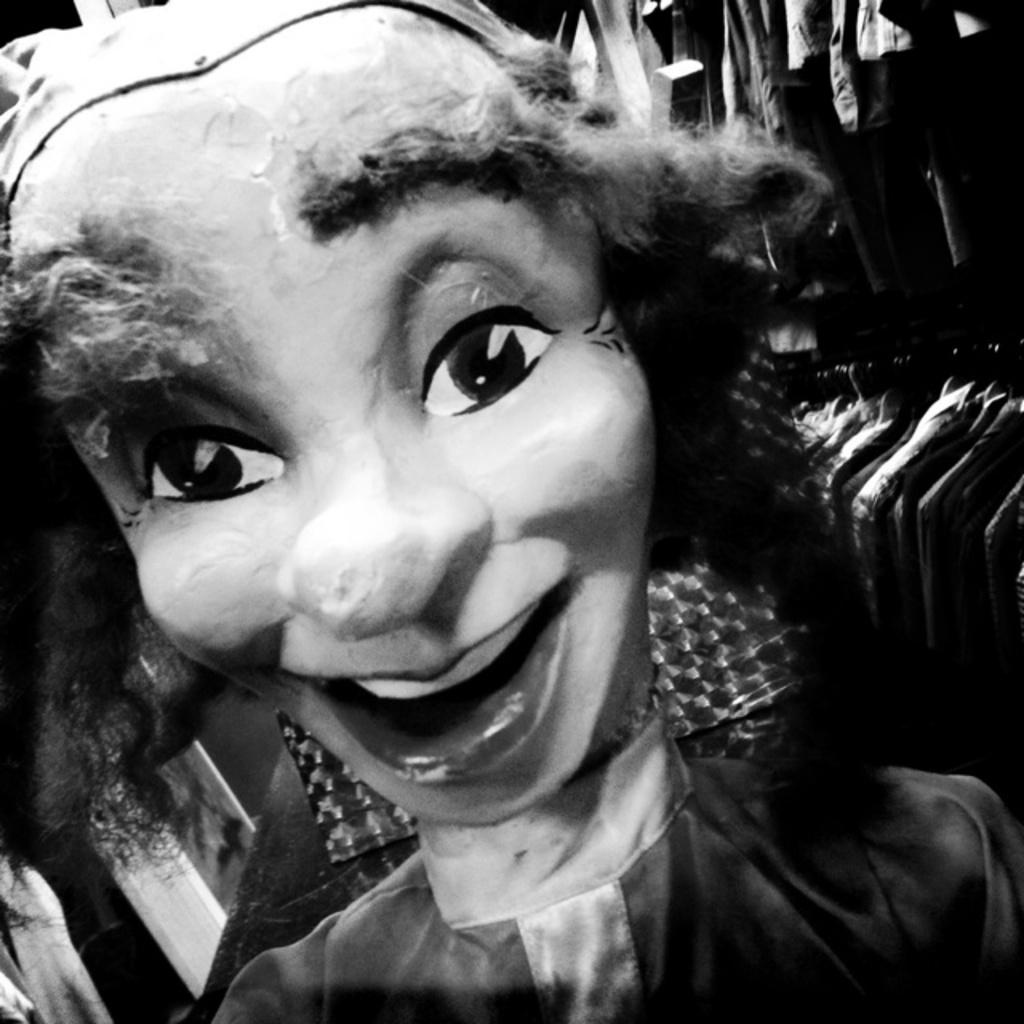What is the main subject of the image? There is a doll in the image. What else can be seen in the background of the image? There are clothes visible in the background of the image. How is the image presented in terms of color? The image is in black and white. Where is the bottle located in the image? There is no bottle present in the image. What type of apple is depicted in the image? There is no apple present in the image. 